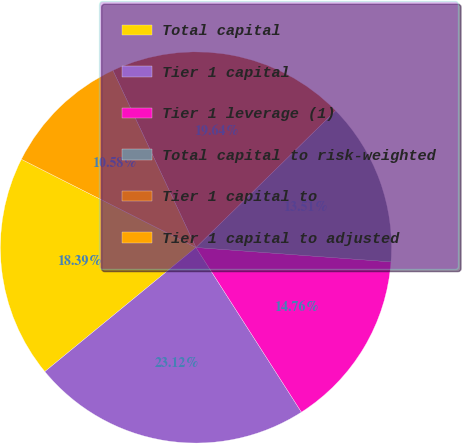Convert chart. <chart><loc_0><loc_0><loc_500><loc_500><pie_chart><fcel>Total capital<fcel>Tier 1 capital<fcel>Tier 1 leverage (1)<fcel>Total capital to risk-weighted<fcel>Tier 1 capital to<fcel>Tier 1 capital to adjusted<nl><fcel>18.39%<fcel>23.12%<fcel>14.76%<fcel>13.51%<fcel>19.64%<fcel>10.58%<nl></chart> 